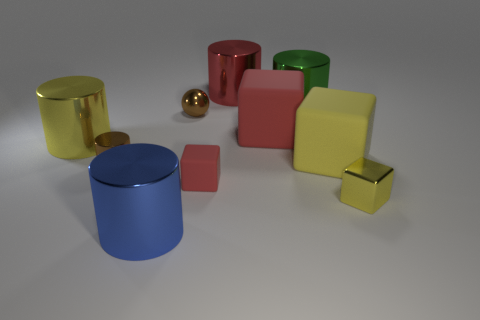Subtract 1 blocks. How many blocks are left? 3 Subtract all yellow cylinders. How many cylinders are left? 4 Subtract all big red cylinders. How many cylinders are left? 4 Subtract all purple cylinders. Subtract all gray cubes. How many cylinders are left? 5 Subtract all spheres. How many objects are left? 9 Add 3 cylinders. How many cylinders exist? 8 Subtract 0 red balls. How many objects are left? 10 Subtract all small yellow shiny cubes. Subtract all tiny shiny cylinders. How many objects are left? 8 Add 8 big red metallic cylinders. How many big red metallic cylinders are left? 9 